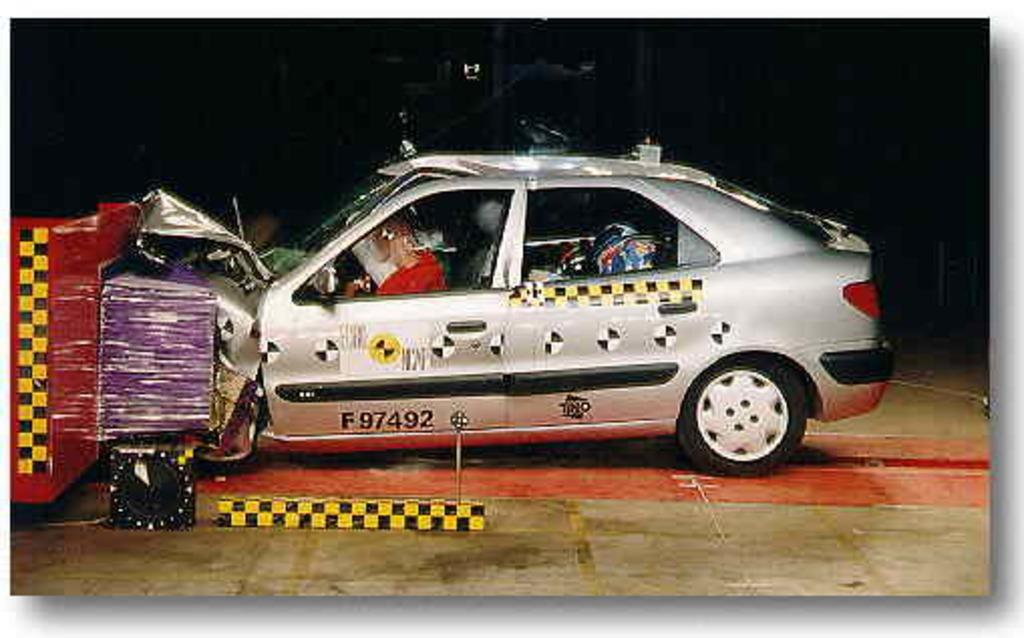What is the main subject of the picture? The main subject of the picture is a scrap car. What are the people inside the car doing? The people are sitting inside the car. How would you describe the background of the car in the image? The background of the car is dark. How would you describe the image quality? The image quality is not clear. Can you tell me how many beggars are visible in the image? There are no beggars present in the image; it features a scrap car with people sitting inside. What type of plantation can be seen in the background of the image? There is no plantation visible in the image; the background is dark. 